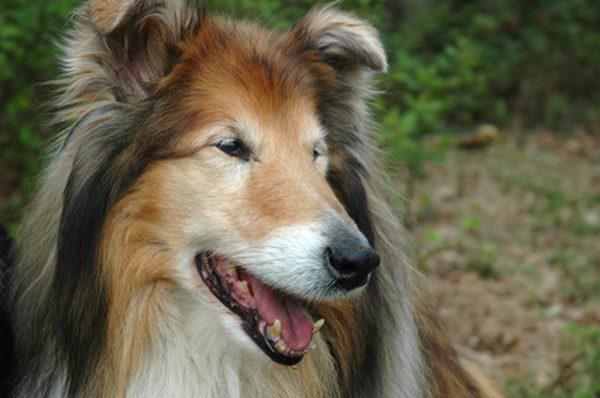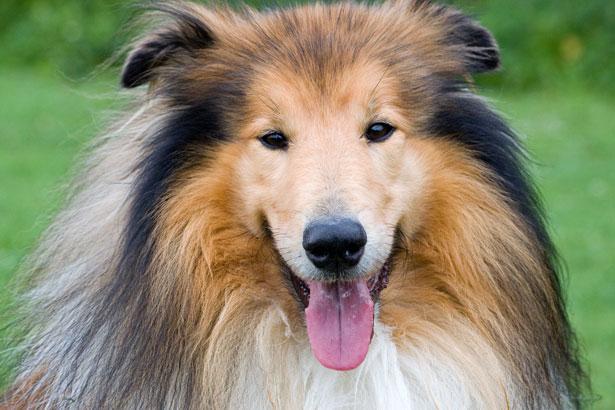The first image is the image on the left, the second image is the image on the right. Assess this claim about the two images: "The dog in the image on the left is looking toward the camera.". Correct or not? Answer yes or no. No. 